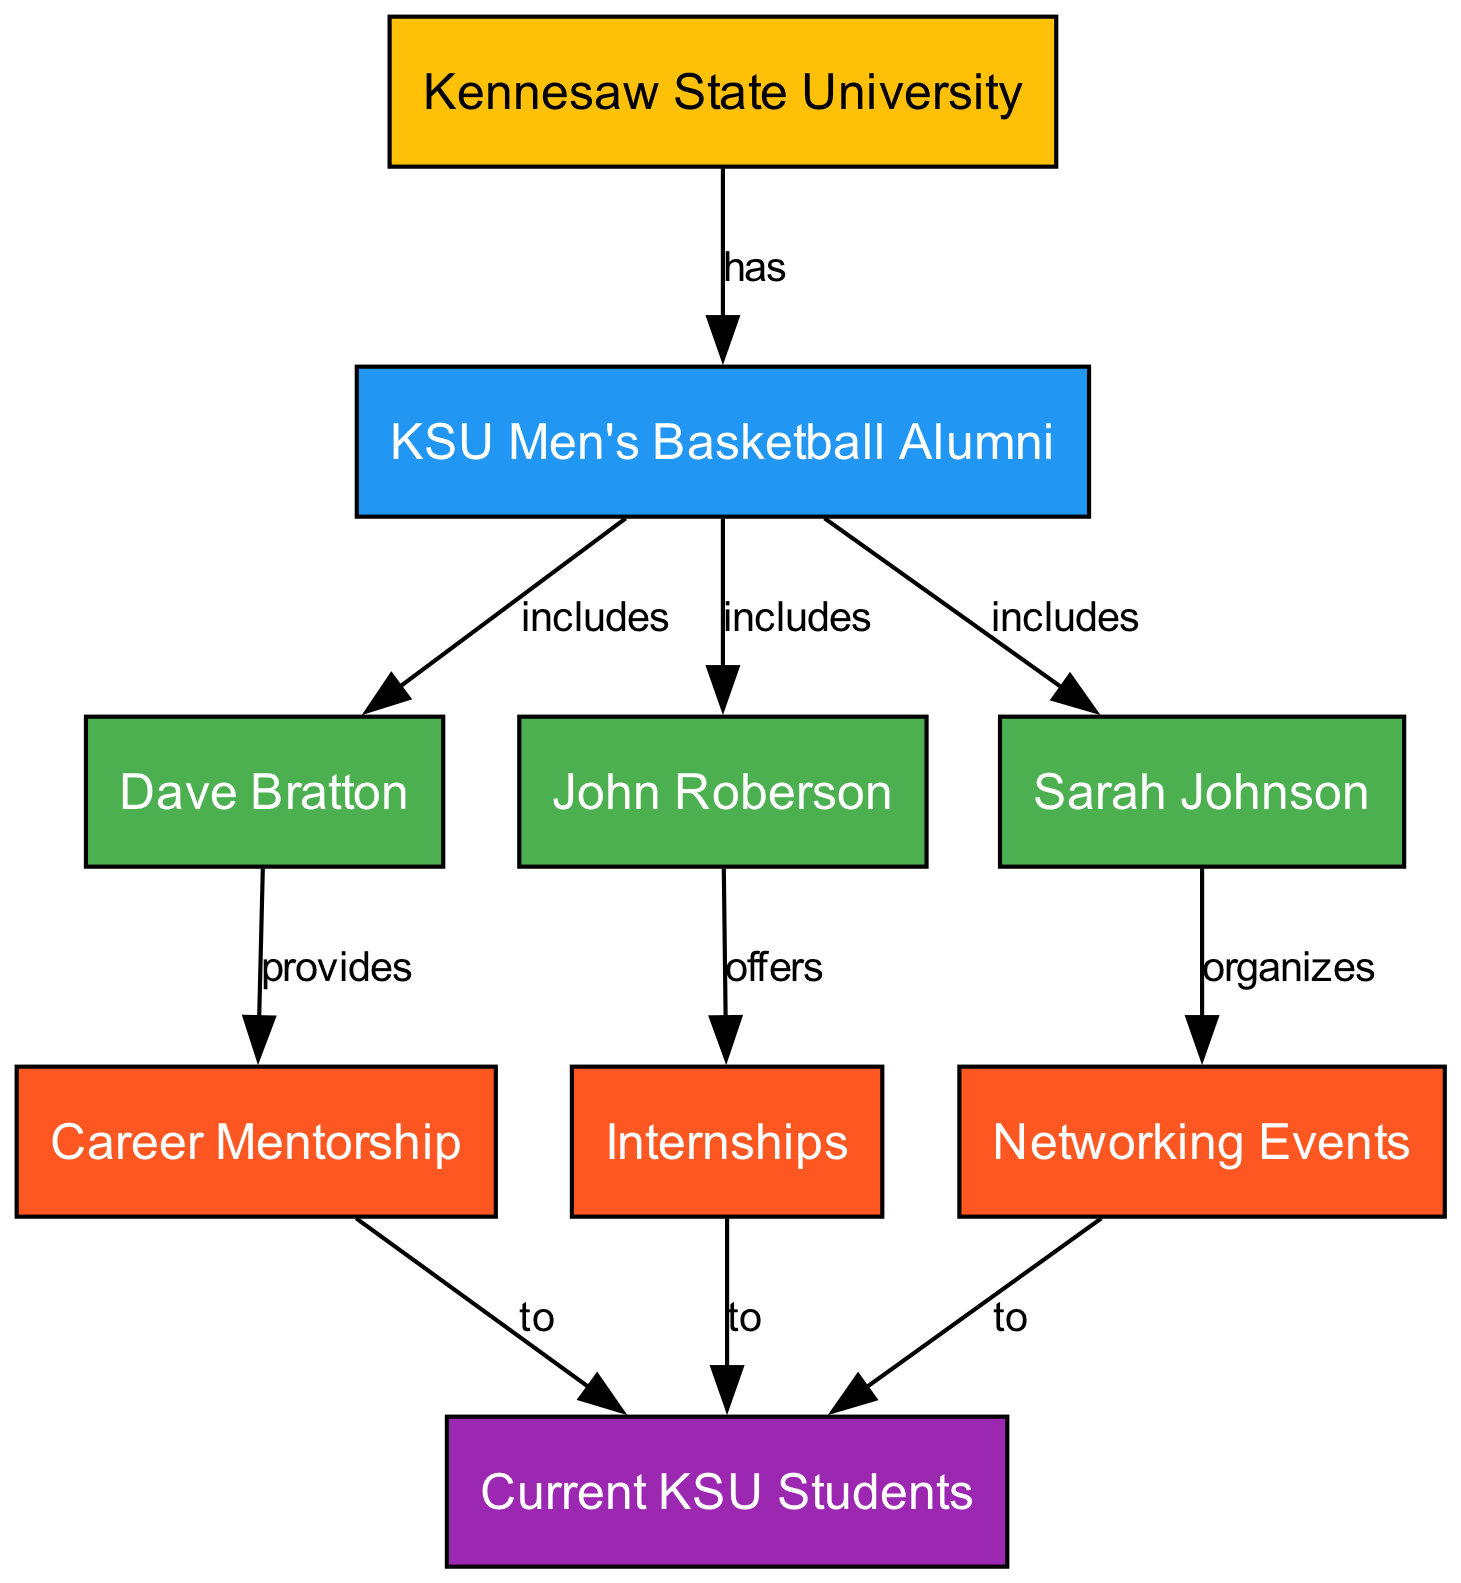What is the main institution represented in the diagram? The diagram starts with a node labeled "Kennesaw State University," indicating that it is the central institution being represented.
Answer: Kennesaw State University How many KSU Men’s Basketball Alumni are represented? The node "KSU Men's Basketball Alumni" has three direct connections leading to three different individuals (Dave Bratton, John Roberson, Sarah Johnson), illustrating that they are included as alumni.
Answer: 3 What support does Dave Bratton provide to current KSU students? The edge from Dave Bratton to "Career Mentorship" indicates that he provides support by mentoring current KSU students.
Answer: Career Mentorship Which alumnus offers internships? The edge from John Roberson leads to "Internships," indicating that he is the alumnus responsible for providing internship opportunities for current students.
Answer: John Roberson What type of opportunities does Sarah Johnson organize for students? The diagram shows an edge from Sarah Johnson to "Networking Events," indicating that she organizes events that help current students connect with alumni and other professionals.
Answer: Networking Events How many types of support are illustrated in the connections to current KSU students? The diagram shows three separate edges leading to "Current KSU Students" from "Career Mentorship," "Internships," and "Networking Events," indicating a total of three types of support available to them.
Answer: 3 Which alumnus is directly linked to networking opportunities for students? The edge pointing from Sarah Johnson to "Networking Events" shows her direct involvement in providing networking opportunities to students.
Answer: Sarah Johnson What is the nature of the relationship between "Kennesaw State University" and "KSU Men's Basketball Alumni"? The relationship is indicated by the edge labeled "has," signifying that the alumni are part of the university's broader community.
Answer: has What does John Roberson offer to current students according to the diagram? The diagram shows that John Roberson has a direct edge leading to "Internships," indicating that he offers this support to current students.
Answer: Internships What type of events are organized by Sarah Johnson for current students? The connection from Sarah Johnson to "Networking Events" clarifies that she organizes such events for the students.
Answer: Networking Events 